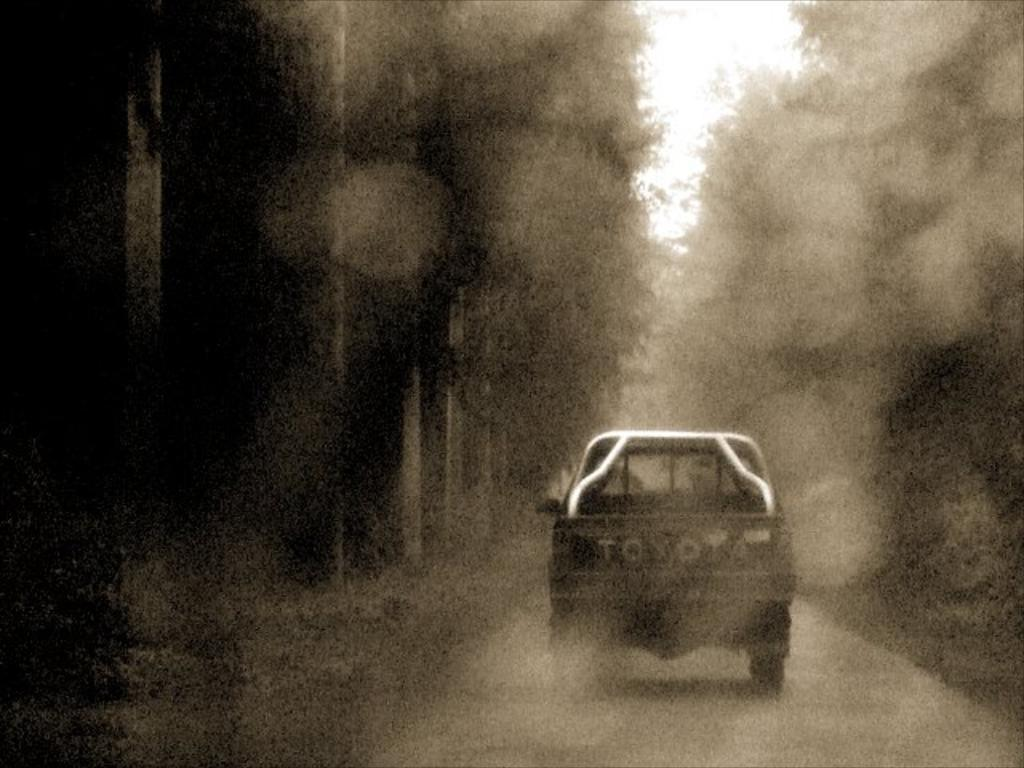What is the main subject of the image? There is a vehicle in the image. Where is the vehicle located? The vehicle is on the road. What type of meat is being served at the wealthiest restaurant in the image? There is no information about any restaurant or meat in the image; it only features a vehicle on the road. 